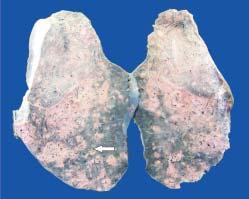what does the sectioned surface of the lung parenchyma show?
Answer the question using a single word or phrase. Presence of minute millet-seed sized tubercles 